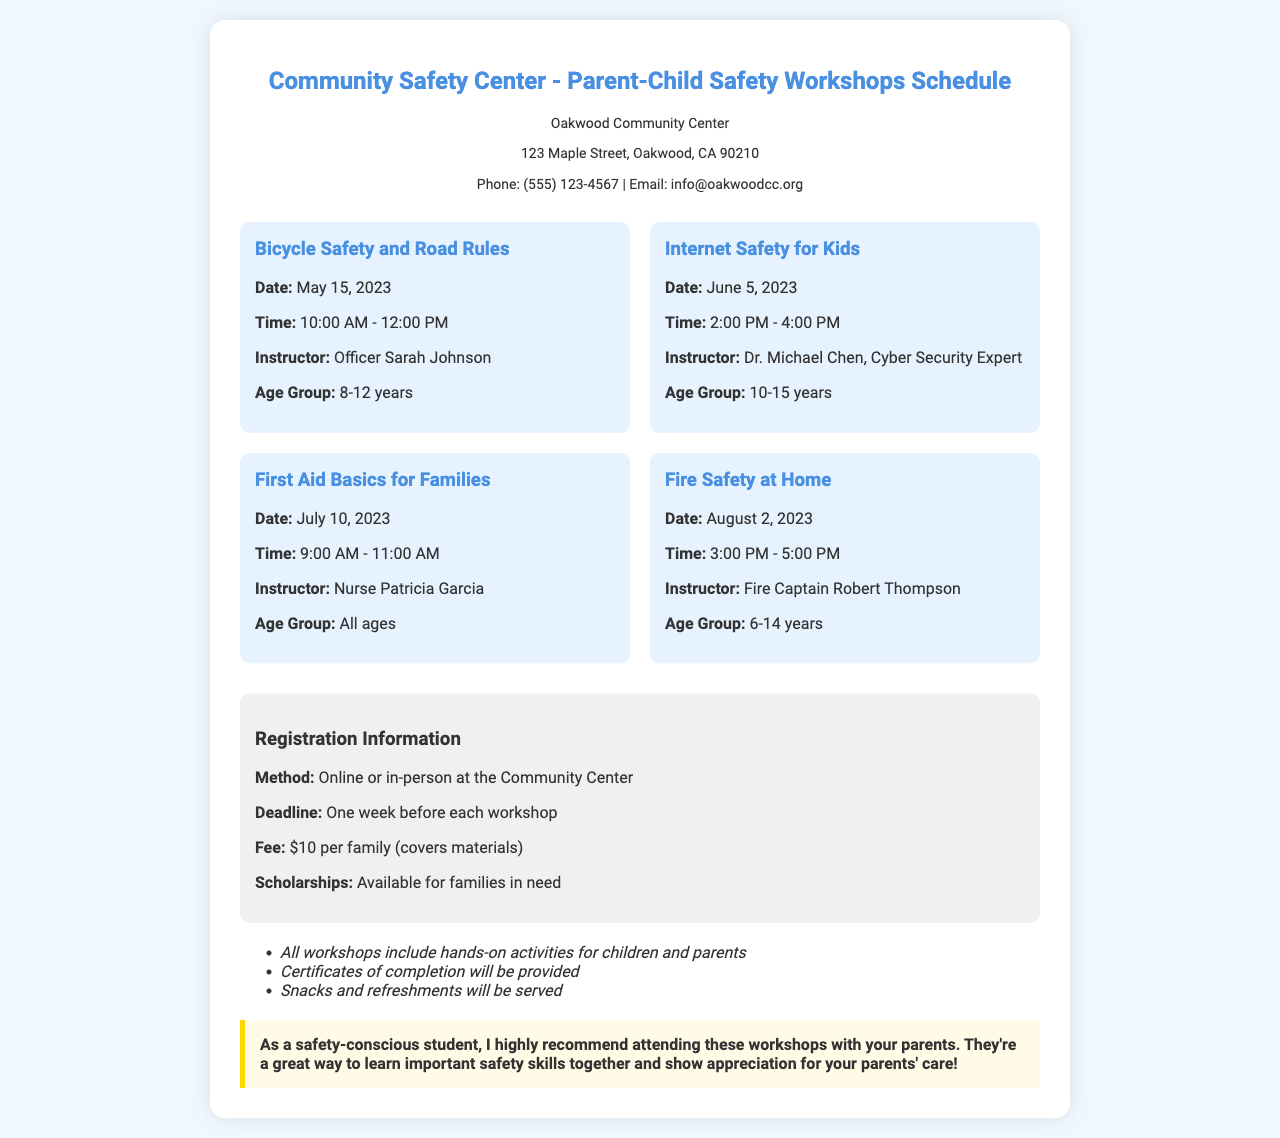What is the title of the document? The title is prominently displayed at the top of the document, which is "Community Safety Center - Parent-Child Safety Workshops Schedule."
Answer: Community Safety Center - Parent-Child Safety Workshops Schedule What is the address of the community center? The address can be found in the contact information section, which mentions the location as "123 Maple Street, Oakwood, CA 90210."
Answer: 123 Maple Street, Oakwood, CA 90210 Who is the instructor for the Internet Safety for Kids workshop? The instructor's name for this specific workshop is listed in the workshop section, which is "Dr. Michael Chen, Cyber Security Expert."
Answer: Dr. Michael Chen, Cyber Security Expert What is the fee for attending the workshops? The fee is mentioned in the registration information section as "$10 per family (covers materials)."
Answer: $10 per family (covers materials) When does the First Aid Basics for Families workshop take place? The date for this workshop is specified in the workshops section, which is "July 10, 2023."
Answer: July 10, 2023 How many hands-on activities are included in the workshops? The document states that "all workshops include hands-on activities for children and parents," indicating that each workshop will have these activities included.
Answer: All workshops What is required for registration? The registration method is detailed in the registration information section, stating that registration can be done "Online or in-person at the Community Center."
Answer: Online or in-person What age group is targeted for the Bicycle Safety and Road Rules workshop? This specific age group is mentioned in the workshop details as "8-12 years."
Answer: 8-12 years Is there any assistance available for families in need? The registration information section notes that there are "scholarships available for families in need."
Answer: Scholarships available for families in need 